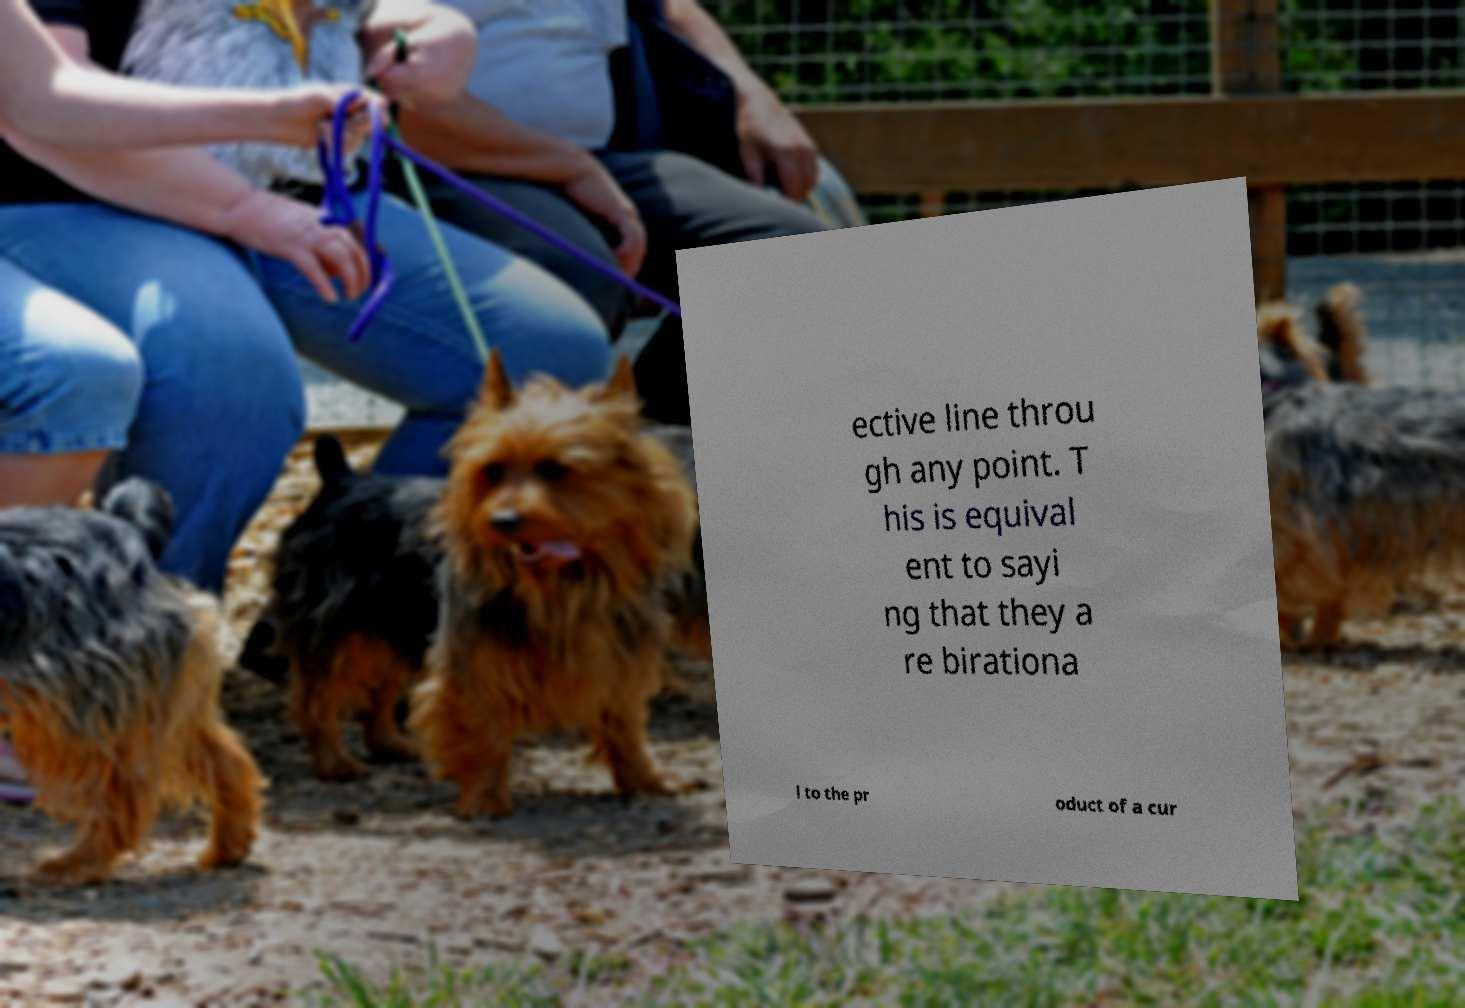I need the written content from this picture converted into text. Can you do that? ective line throu gh any point. T his is equival ent to sayi ng that they a re birationa l to the pr oduct of a cur 